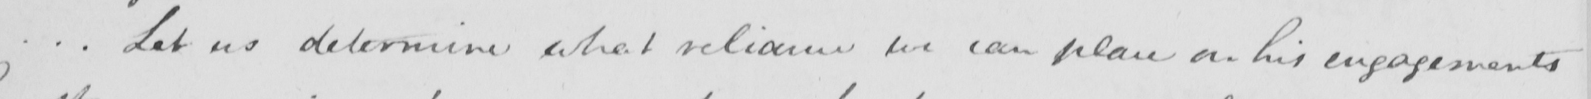What text is written in this handwritten line? .  .  . Let us determine what reliance we can place on his engagements 